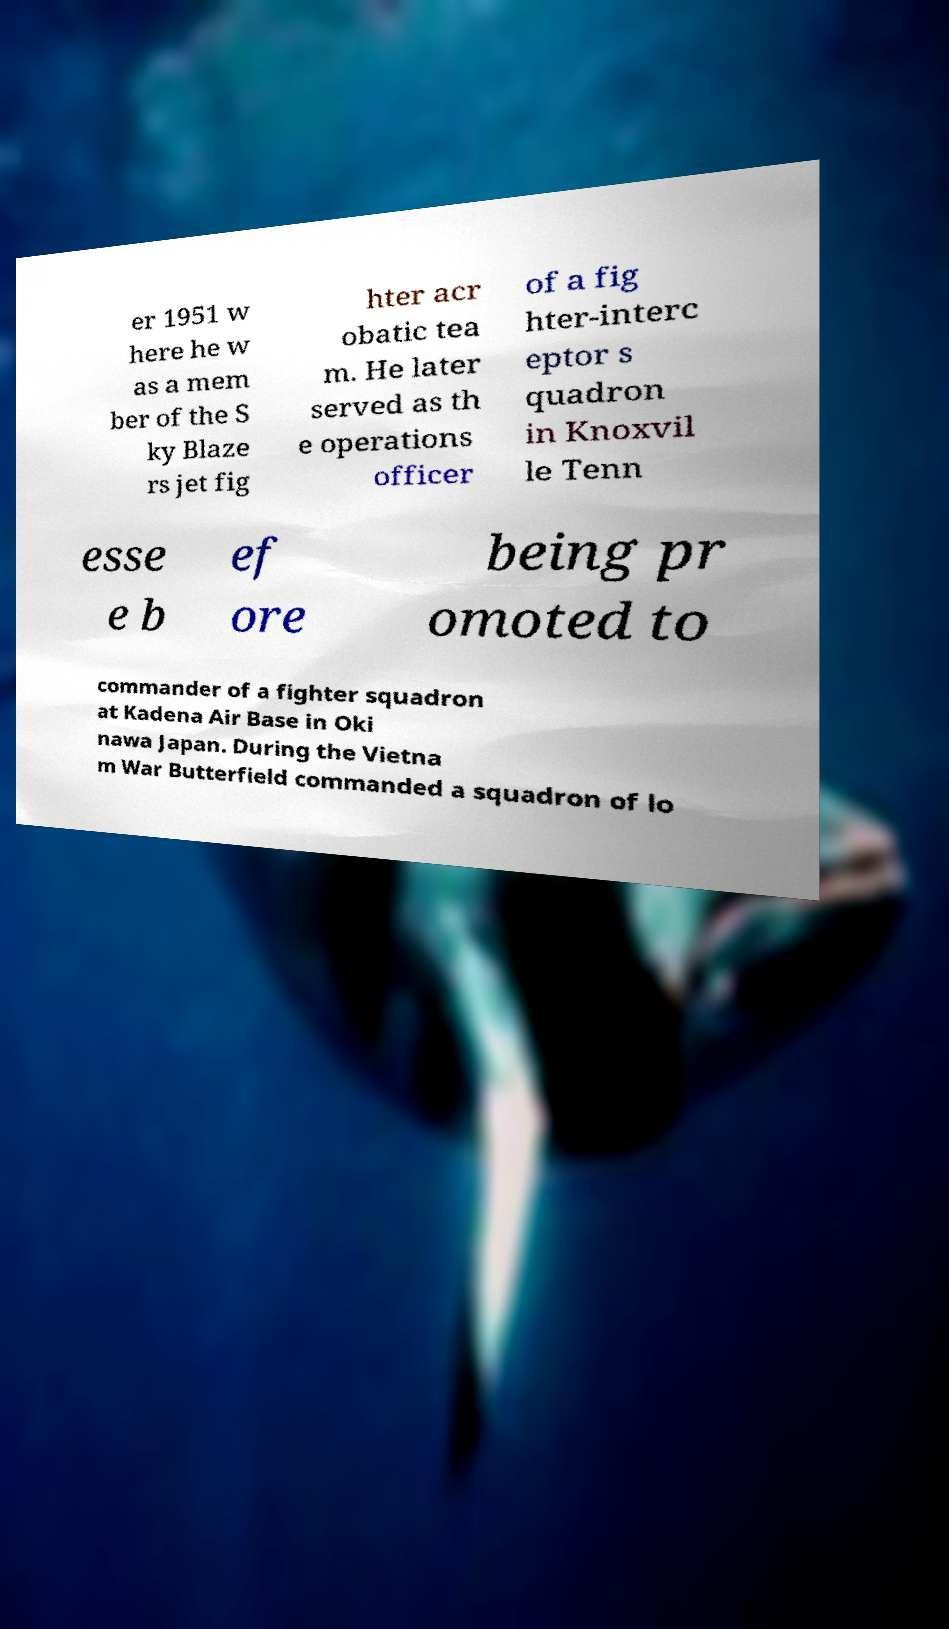What messages or text are displayed in this image? I need them in a readable, typed format. er 1951 w here he w as a mem ber of the S ky Blaze rs jet fig hter acr obatic tea m. He later served as th e operations officer of a fig hter-interc eptor s quadron in Knoxvil le Tenn esse e b ef ore being pr omoted to commander of a fighter squadron at Kadena Air Base in Oki nawa Japan. During the Vietna m War Butterfield commanded a squadron of lo 